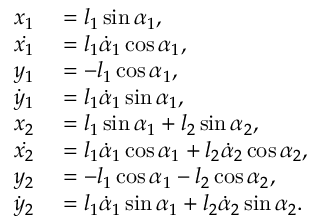Convert formula to latex. <formula><loc_0><loc_0><loc_500><loc_500>\begin{array} { r l } { x _ { 1 } } & = l _ { 1 } \sin \alpha _ { 1 } , } \\ { \dot { x _ { 1 } } } & = l _ { 1 } \dot { \alpha } _ { 1 } \cos \alpha _ { 1 } , } \\ { y _ { 1 } } & = - l _ { 1 } \cos \alpha _ { 1 } , } \\ { \dot { y } _ { 1 } } & = l _ { 1 } \dot { \alpha } _ { 1 } \sin \alpha _ { 1 } , } \\ { x _ { 2 } } & = l _ { 1 } \sin \alpha _ { 1 } + l _ { 2 } \sin \alpha _ { 2 } , } \\ { \dot { x _ { 2 } } } & = l _ { 1 } \dot { \alpha } _ { 1 } \cos \alpha _ { 1 } + l _ { 2 } \dot { \alpha } _ { 2 } \cos \alpha _ { 2 } , } \\ { y _ { 2 } } & = - l _ { 1 } \cos \alpha _ { 1 } - l _ { 2 } \cos \alpha _ { 2 } , } \\ { \dot { y } _ { 2 } } & = l _ { 1 } \dot { \alpha } _ { 1 } \sin \alpha _ { 1 } + l _ { 2 } \dot { \alpha } _ { 2 } \sin \alpha _ { 2 } . } \end{array}</formula> 